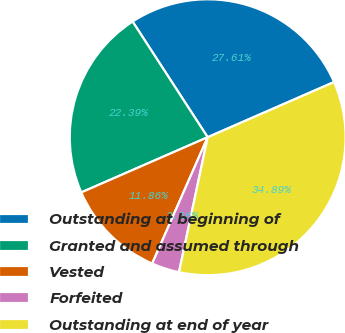Convert chart to OTSL. <chart><loc_0><loc_0><loc_500><loc_500><pie_chart><fcel>Outstanding at beginning of<fcel>Granted and assumed through<fcel>Vested<fcel>Forfeited<fcel>Outstanding at end of year<nl><fcel>27.61%<fcel>22.39%<fcel>11.86%<fcel>3.26%<fcel>34.89%<nl></chart> 